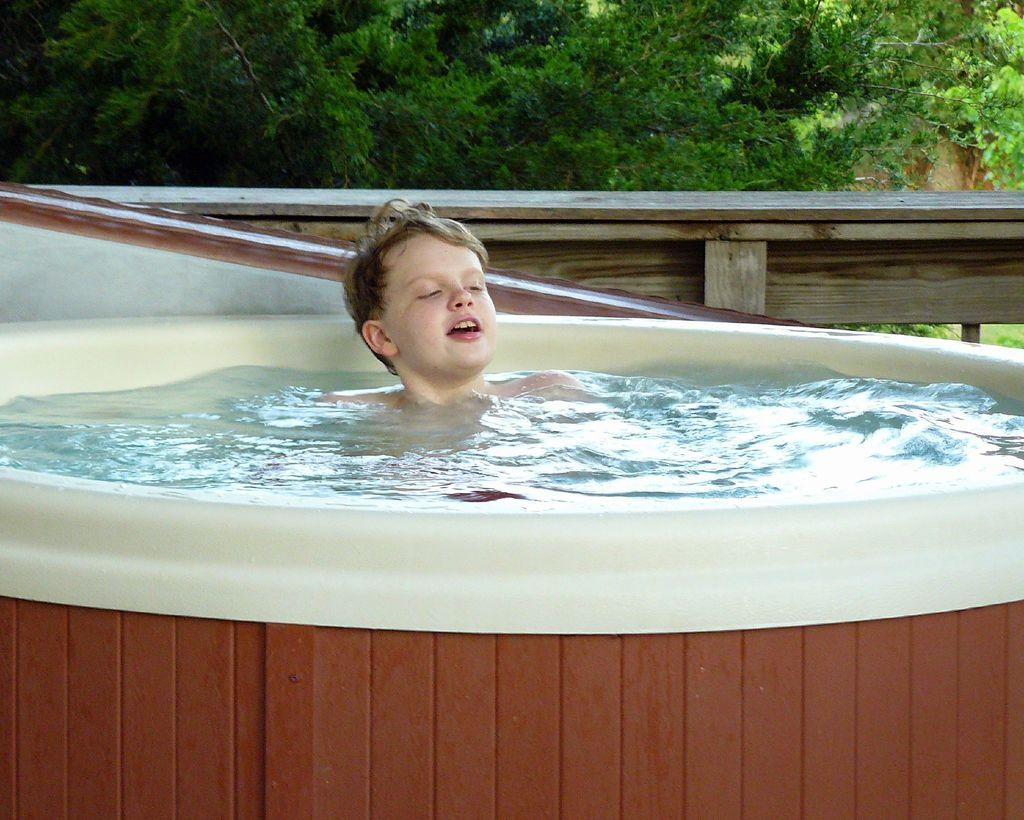Who or what is present in the image? There is a person in the image. What is the person doing or where are they located? The person is in the water. What can be seen in the background of the image? There is a wooden object in the background of the image, and the trees are green. What type of quiver is the beggar holding in the image? There is no beggar or quiver present in the image. Is there a birthday celebration happening in the image? There is no indication of a birthday celebration in the image. 